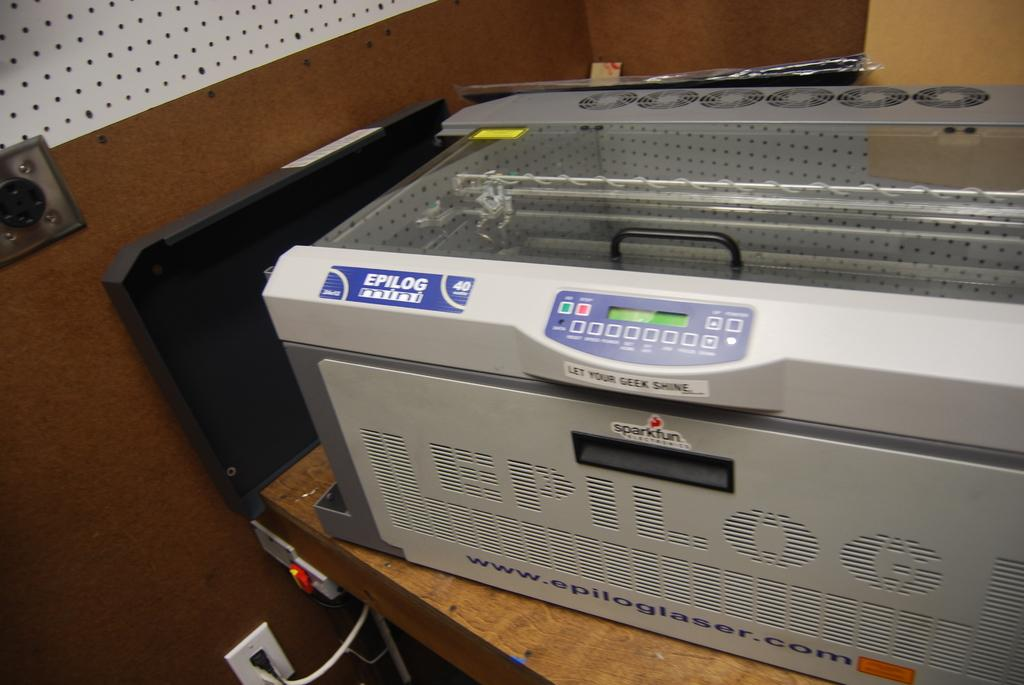<image>
Render a clear and concise summary of the photo. At the bottom of an Epilog laser printer is the website www.epiloglaser.com. 